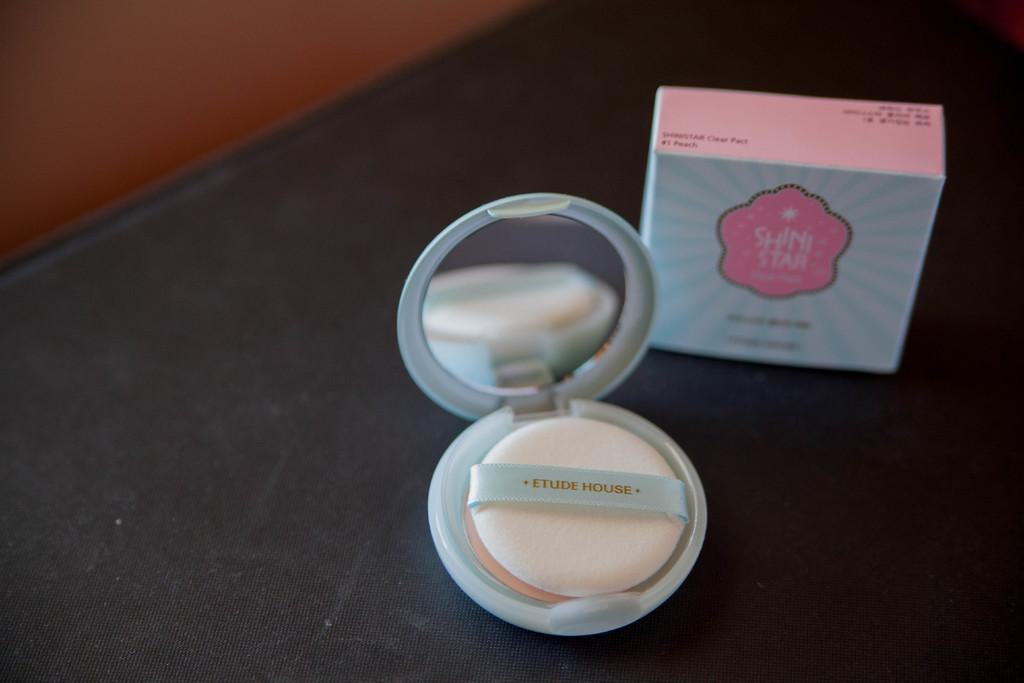<image>
Offer a succinct explanation of the picture presented. A box that says Shini Star is on a black table next to a make up container. 